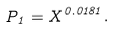Convert formula to latex. <formula><loc_0><loc_0><loc_500><loc_500>P _ { 1 } = X ^ { 0 . 0 1 8 1 } .</formula> 